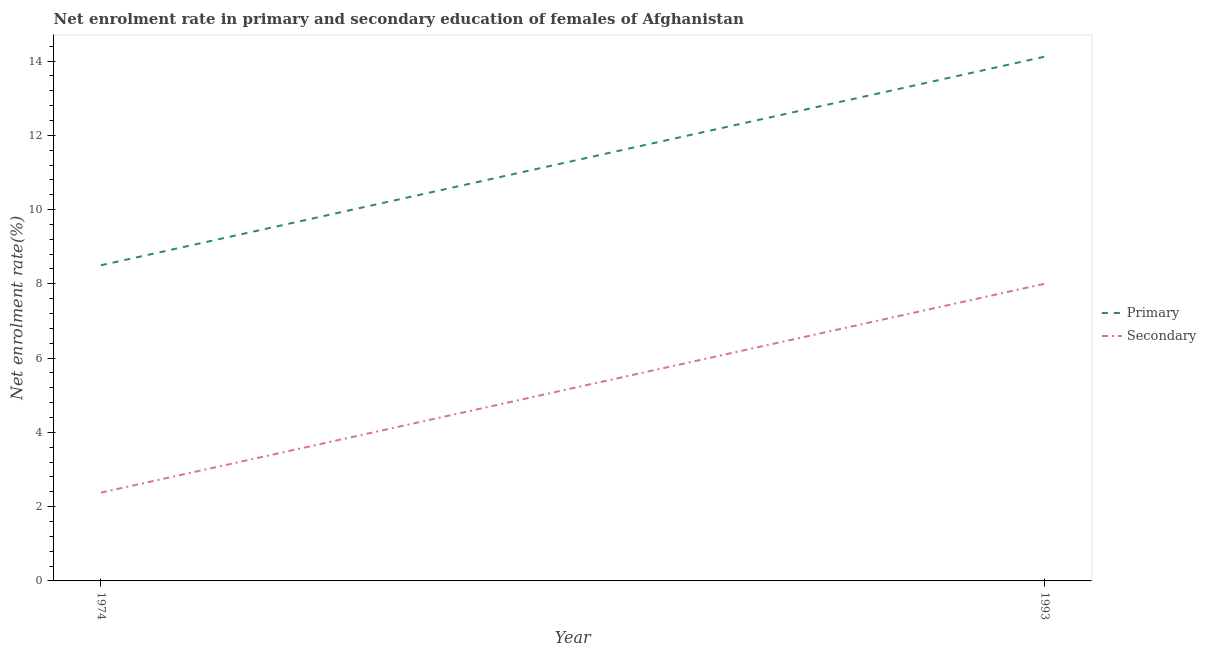What is the enrollment rate in secondary education in 1993?
Your response must be concise. 8. Across all years, what is the maximum enrollment rate in primary education?
Ensure brevity in your answer.  14.12. Across all years, what is the minimum enrollment rate in secondary education?
Ensure brevity in your answer.  2.38. In which year was the enrollment rate in secondary education maximum?
Offer a very short reply. 1993. In which year was the enrollment rate in primary education minimum?
Provide a succinct answer. 1974. What is the total enrollment rate in secondary education in the graph?
Give a very brief answer. 10.38. What is the difference between the enrollment rate in primary education in 1974 and that in 1993?
Provide a succinct answer. -5.62. What is the difference between the enrollment rate in primary education in 1974 and the enrollment rate in secondary education in 1993?
Offer a very short reply. 0.5. What is the average enrollment rate in secondary education per year?
Offer a very short reply. 5.19. In the year 1993, what is the difference between the enrollment rate in primary education and enrollment rate in secondary education?
Give a very brief answer. 6.11. In how many years, is the enrollment rate in secondary education greater than 9.6 %?
Provide a short and direct response. 0. What is the ratio of the enrollment rate in secondary education in 1974 to that in 1993?
Give a very brief answer. 0.3. Is the enrollment rate in secondary education in 1974 less than that in 1993?
Give a very brief answer. Yes. Is the enrollment rate in secondary education strictly greater than the enrollment rate in primary education over the years?
Your response must be concise. No. How many years are there in the graph?
Offer a terse response. 2. Does the graph contain any zero values?
Provide a succinct answer. No. Does the graph contain grids?
Offer a very short reply. No. Where does the legend appear in the graph?
Make the answer very short. Center right. How many legend labels are there?
Provide a succinct answer. 2. What is the title of the graph?
Your answer should be very brief. Net enrolment rate in primary and secondary education of females of Afghanistan. What is the label or title of the X-axis?
Keep it short and to the point. Year. What is the label or title of the Y-axis?
Your answer should be very brief. Net enrolment rate(%). What is the Net enrolment rate(%) of Primary in 1974?
Your response must be concise. 8.5. What is the Net enrolment rate(%) in Secondary in 1974?
Ensure brevity in your answer.  2.38. What is the Net enrolment rate(%) of Primary in 1993?
Your response must be concise. 14.12. What is the Net enrolment rate(%) in Secondary in 1993?
Offer a very short reply. 8. Across all years, what is the maximum Net enrolment rate(%) of Primary?
Your answer should be very brief. 14.12. Across all years, what is the maximum Net enrolment rate(%) of Secondary?
Your answer should be compact. 8. Across all years, what is the minimum Net enrolment rate(%) of Primary?
Offer a terse response. 8.5. Across all years, what is the minimum Net enrolment rate(%) in Secondary?
Give a very brief answer. 2.38. What is the total Net enrolment rate(%) in Primary in the graph?
Keep it short and to the point. 22.62. What is the total Net enrolment rate(%) of Secondary in the graph?
Provide a short and direct response. 10.38. What is the difference between the Net enrolment rate(%) of Primary in 1974 and that in 1993?
Make the answer very short. -5.62. What is the difference between the Net enrolment rate(%) in Secondary in 1974 and that in 1993?
Your response must be concise. -5.62. What is the difference between the Net enrolment rate(%) of Primary in 1974 and the Net enrolment rate(%) of Secondary in 1993?
Provide a short and direct response. 0.5. What is the average Net enrolment rate(%) of Primary per year?
Offer a terse response. 11.31. What is the average Net enrolment rate(%) of Secondary per year?
Your answer should be very brief. 5.19. In the year 1974, what is the difference between the Net enrolment rate(%) in Primary and Net enrolment rate(%) in Secondary?
Provide a short and direct response. 6.12. In the year 1993, what is the difference between the Net enrolment rate(%) in Primary and Net enrolment rate(%) in Secondary?
Provide a succinct answer. 6.12. What is the ratio of the Net enrolment rate(%) in Primary in 1974 to that in 1993?
Your answer should be compact. 0.6. What is the ratio of the Net enrolment rate(%) in Secondary in 1974 to that in 1993?
Offer a very short reply. 0.3. What is the difference between the highest and the second highest Net enrolment rate(%) in Primary?
Your response must be concise. 5.62. What is the difference between the highest and the second highest Net enrolment rate(%) of Secondary?
Your answer should be compact. 5.62. What is the difference between the highest and the lowest Net enrolment rate(%) of Primary?
Offer a terse response. 5.62. What is the difference between the highest and the lowest Net enrolment rate(%) of Secondary?
Your response must be concise. 5.62. 